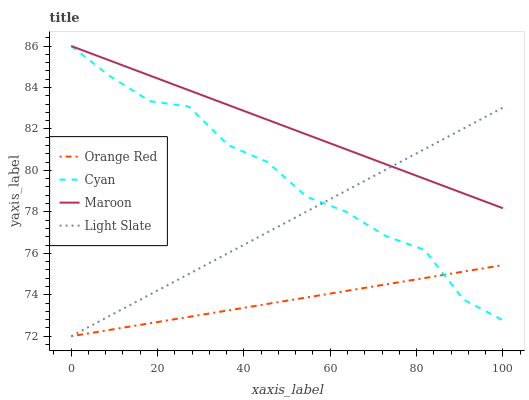Does Orange Red have the minimum area under the curve?
Answer yes or no. Yes. Does Maroon have the maximum area under the curve?
Answer yes or no. Yes. Does Cyan have the minimum area under the curve?
Answer yes or no. No. Does Cyan have the maximum area under the curve?
Answer yes or no. No. Is Light Slate the smoothest?
Answer yes or no. Yes. Is Cyan the roughest?
Answer yes or no. Yes. Is Orange Red the smoothest?
Answer yes or no. No. Is Orange Red the roughest?
Answer yes or no. No. Does Light Slate have the lowest value?
Answer yes or no. Yes. Does Cyan have the lowest value?
Answer yes or no. No. Does Maroon have the highest value?
Answer yes or no. Yes. Does Orange Red have the highest value?
Answer yes or no. No. Is Orange Red less than Maroon?
Answer yes or no. Yes. Is Maroon greater than Orange Red?
Answer yes or no. Yes. Does Cyan intersect Maroon?
Answer yes or no. Yes. Is Cyan less than Maroon?
Answer yes or no. No. Is Cyan greater than Maroon?
Answer yes or no. No. Does Orange Red intersect Maroon?
Answer yes or no. No. 